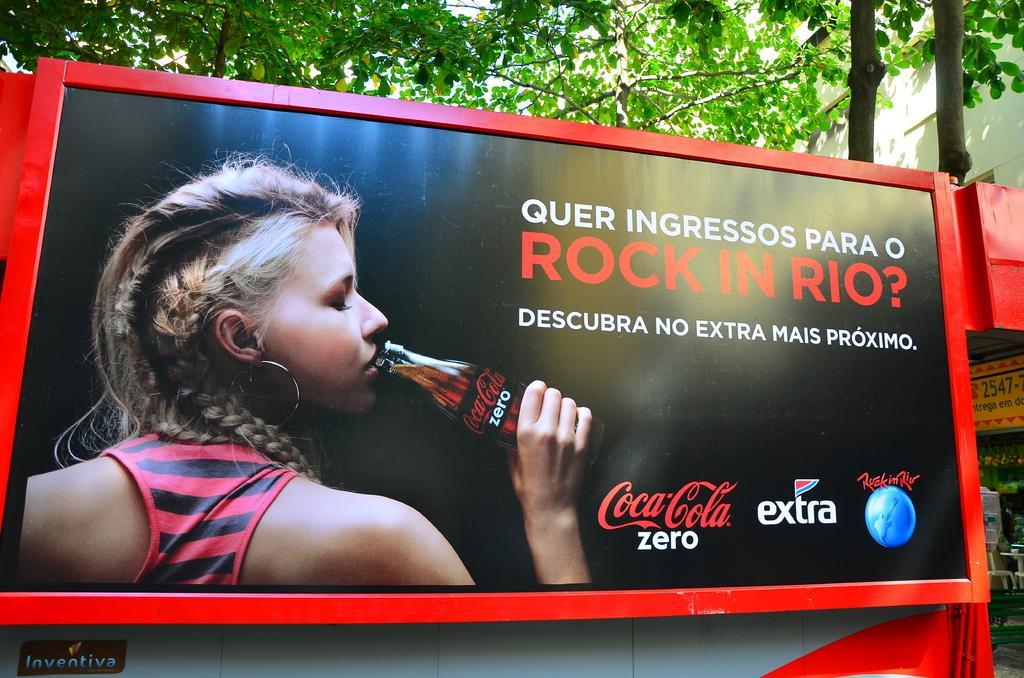Please provide a concise description of this image. In this image I can see a board on which there is some text and an image of a woman who is holding a bottle in the hand and drinking. On the right side there is a stall and few chairs. At the top of the image the leaves are visible. In the top right-hand corner there is a building. 